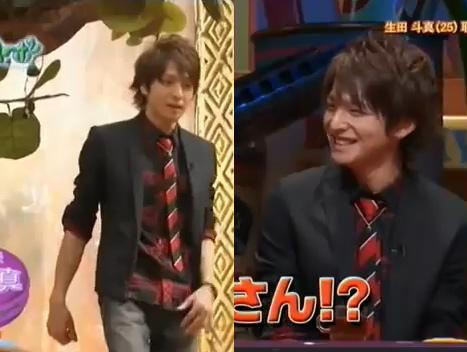Where would the contents of this image probably be seen exactly assis? Please explain your reasoning. on tv. The image has subtitles. 